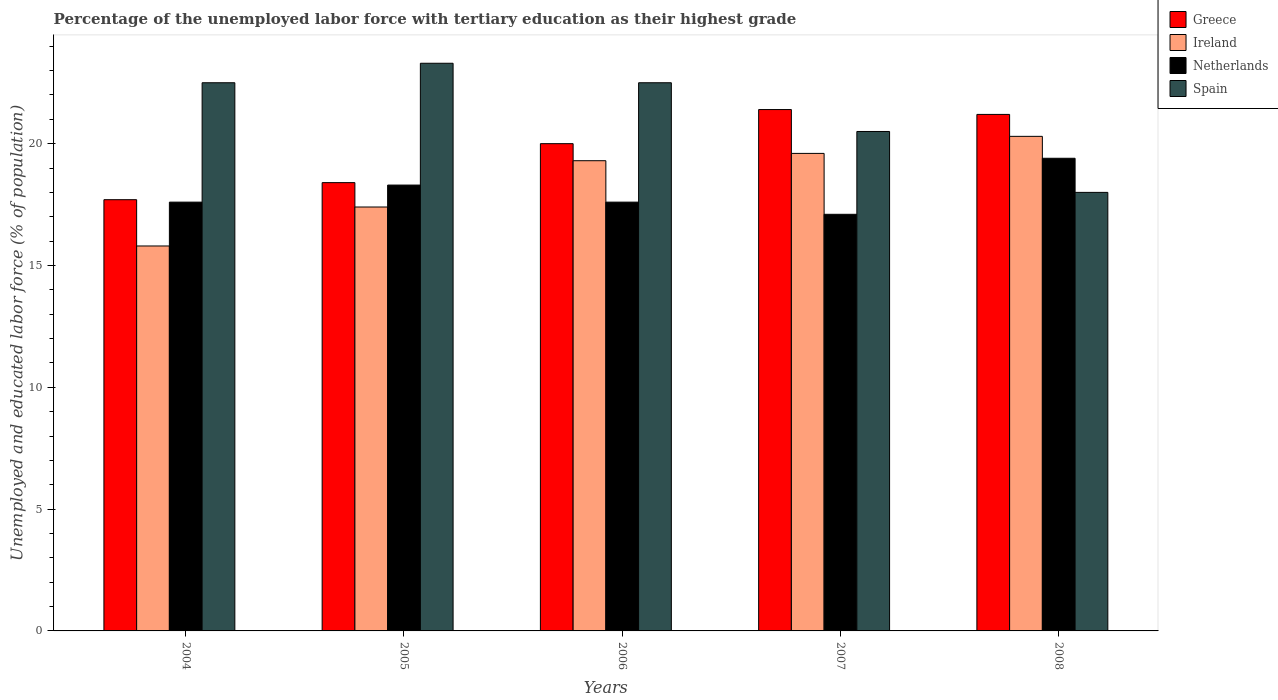How many different coloured bars are there?
Make the answer very short. 4. How many groups of bars are there?
Your answer should be compact. 5. Are the number of bars on each tick of the X-axis equal?
Your answer should be compact. Yes. How many bars are there on the 2nd tick from the left?
Your answer should be compact. 4. What is the percentage of the unemployed labor force with tertiary education in Ireland in 2005?
Your answer should be very brief. 17.4. Across all years, what is the maximum percentage of the unemployed labor force with tertiary education in Spain?
Offer a terse response. 23.3. In which year was the percentage of the unemployed labor force with tertiary education in Spain minimum?
Keep it short and to the point. 2008. What is the total percentage of the unemployed labor force with tertiary education in Spain in the graph?
Ensure brevity in your answer.  106.8. What is the difference between the percentage of the unemployed labor force with tertiary education in Netherlands in 2008 and the percentage of the unemployed labor force with tertiary education in Spain in 2005?
Provide a short and direct response. -3.9. What is the average percentage of the unemployed labor force with tertiary education in Ireland per year?
Ensure brevity in your answer.  18.48. In the year 2006, what is the difference between the percentage of the unemployed labor force with tertiary education in Ireland and percentage of the unemployed labor force with tertiary education in Greece?
Keep it short and to the point. -0.7. What is the ratio of the percentage of the unemployed labor force with tertiary education in Spain in 2004 to that in 2008?
Offer a terse response. 1.25. Is the difference between the percentage of the unemployed labor force with tertiary education in Ireland in 2005 and 2008 greater than the difference between the percentage of the unemployed labor force with tertiary education in Greece in 2005 and 2008?
Make the answer very short. No. What is the difference between the highest and the second highest percentage of the unemployed labor force with tertiary education in Greece?
Your answer should be compact. 0.2. What is the difference between the highest and the lowest percentage of the unemployed labor force with tertiary education in Greece?
Your answer should be very brief. 3.7. In how many years, is the percentage of the unemployed labor force with tertiary education in Greece greater than the average percentage of the unemployed labor force with tertiary education in Greece taken over all years?
Make the answer very short. 3. What does the 1st bar from the left in 2004 represents?
Your response must be concise. Greece. Is it the case that in every year, the sum of the percentage of the unemployed labor force with tertiary education in Ireland and percentage of the unemployed labor force with tertiary education in Netherlands is greater than the percentage of the unemployed labor force with tertiary education in Spain?
Offer a very short reply. Yes. Are all the bars in the graph horizontal?
Your response must be concise. No. How many years are there in the graph?
Give a very brief answer. 5. What is the difference between two consecutive major ticks on the Y-axis?
Offer a very short reply. 5. Are the values on the major ticks of Y-axis written in scientific E-notation?
Your answer should be compact. No. Does the graph contain any zero values?
Provide a succinct answer. No. Where does the legend appear in the graph?
Offer a very short reply. Top right. How many legend labels are there?
Provide a short and direct response. 4. How are the legend labels stacked?
Your answer should be compact. Vertical. What is the title of the graph?
Offer a very short reply. Percentage of the unemployed labor force with tertiary education as their highest grade. Does "East Asia (all income levels)" appear as one of the legend labels in the graph?
Offer a very short reply. No. What is the label or title of the X-axis?
Make the answer very short. Years. What is the label or title of the Y-axis?
Give a very brief answer. Unemployed and educated labor force (% of population). What is the Unemployed and educated labor force (% of population) of Greece in 2004?
Your answer should be very brief. 17.7. What is the Unemployed and educated labor force (% of population) of Ireland in 2004?
Your answer should be compact. 15.8. What is the Unemployed and educated labor force (% of population) of Netherlands in 2004?
Make the answer very short. 17.6. What is the Unemployed and educated labor force (% of population) of Greece in 2005?
Ensure brevity in your answer.  18.4. What is the Unemployed and educated labor force (% of population) in Ireland in 2005?
Provide a succinct answer. 17.4. What is the Unemployed and educated labor force (% of population) of Netherlands in 2005?
Give a very brief answer. 18.3. What is the Unemployed and educated labor force (% of population) in Spain in 2005?
Offer a terse response. 23.3. What is the Unemployed and educated labor force (% of population) of Ireland in 2006?
Your answer should be compact. 19.3. What is the Unemployed and educated labor force (% of population) in Netherlands in 2006?
Ensure brevity in your answer.  17.6. What is the Unemployed and educated labor force (% of population) of Greece in 2007?
Make the answer very short. 21.4. What is the Unemployed and educated labor force (% of population) of Ireland in 2007?
Give a very brief answer. 19.6. What is the Unemployed and educated labor force (% of population) of Netherlands in 2007?
Ensure brevity in your answer.  17.1. What is the Unemployed and educated labor force (% of population) of Spain in 2007?
Your answer should be very brief. 20.5. What is the Unemployed and educated labor force (% of population) in Greece in 2008?
Give a very brief answer. 21.2. What is the Unemployed and educated labor force (% of population) in Ireland in 2008?
Keep it short and to the point. 20.3. What is the Unemployed and educated labor force (% of population) in Netherlands in 2008?
Ensure brevity in your answer.  19.4. What is the Unemployed and educated labor force (% of population) in Spain in 2008?
Your response must be concise. 18. Across all years, what is the maximum Unemployed and educated labor force (% of population) in Greece?
Make the answer very short. 21.4. Across all years, what is the maximum Unemployed and educated labor force (% of population) in Ireland?
Your response must be concise. 20.3. Across all years, what is the maximum Unemployed and educated labor force (% of population) in Netherlands?
Your answer should be compact. 19.4. Across all years, what is the maximum Unemployed and educated labor force (% of population) of Spain?
Offer a terse response. 23.3. Across all years, what is the minimum Unemployed and educated labor force (% of population) in Greece?
Make the answer very short. 17.7. Across all years, what is the minimum Unemployed and educated labor force (% of population) in Ireland?
Your answer should be very brief. 15.8. Across all years, what is the minimum Unemployed and educated labor force (% of population) of Netherlands?
Ensure brevity in your answer.  17.1. Across all years, what is the minimum Unemployed and educated labor force (% of population) in Spain?
Your answer should be compact. 18. What is the total Unemployed and educated labor force (% of population) of Greece in the graph?
Ensure brevity in your answer.  98.7. What is the total Unemployed and educated labor force (% of population) in Ireland in the graph?
Offer a terse response. 92.4. What is the total Unemployed and educated labor force (% of population) in Spain in the graph?
Offer a very short reply. 106.8. What is the difference between the Unemployed and educated labor force (% of population) of Netherlands in 2004 and that in 2005?
Keep it short and to the point. -0.7. What is the difference between the Unemployed and educated labor force (% of population) in Spain in 2004 and that in 2005?
Offer a terse response. -0.8. What is the difference between the Unemployed and educated labor force (% of population) in Greece in 2004 and that in 2007?
Your answer should be compact. -3.7. What is the difference between the Unemployed and educated labor force (% of population) of Netherlands in 2004 and that in 2008?
Offer a terse response. -1.8. What is the difference between the Unemployed and educated labor force (% of population) in Ireland in 2005 and that in 2006?
Your answer should be very brief. -1.9. What is the difference between the Unemployed and educated labor force (% of population) of Netherlands in 2005 and that in 2006?
Provide a succinct answer. 0.7. What is the difference between the Unemployed and educated labor force (% of population) of Spain in 2005 and that in 2006?
Give a very brief answer. 0.8. What is the difference between the Unemployed and educated labor force (% of population) in Netherlands in 2005 and that in 2007?
Offer a terse response. 1.2. What is the difference between the Unemployed and educated labor force (% of population) of Spain in 2005 and that in 2007?
Offer a very short reply. 2.8. What is the difference between the Unemployed and educated labor force (% of population) of Greece in 2005 and that in 2008?
Provide a short and direct response. -2.8. What is the difference between the Unemployed and educated labor force (% of population) of Ireland in 2005 and that in 2008?
Offer a terse response. -2.9. What is the difference between the Unemployed and educated labor force (% of population) in Spain in 2005 and that in 2008?
Keep it short and to the point. 5.3. What is the difference between the Unemployed and educated labor force (% of population) in Greece in 2006 and that in 2007?
Your response must be concise. -1.4. What is the difference between the Unemployed and educated labor force (% of population) of Netherlands in 2006 and that in 2007?
Offer a terse response. 0.5. What is the difference between the Unemployed and educated labor force (% of population) in Spain in 2006 and that in 2007?
Make the answer very short. 2. What is the difference between the Unemployed and educated labor force (% of population) in Ireland in 2007 and that in 2008?
Give a very brief answer. -0.7. What is the difference between the Unemployed and educated labor force (% of population) of Greece in 2004 and the Unemployed and educated labor force (% of population) of Netherlands in 2005?
Your response must be concise. -0.6. What is the difference between the Unemployed and educated labor force (% of population) in Greece in 2004 and the Unemployed and educated labor force (% of population) in Spain in 2005?
Give a very brief answer. -5.6. What is the difference between the Unemployed and educated labor force (% of population) of Ireland in 2004 and the Unemployed and educated labor force (% of population) of Netherlands in 2005?
Give a very brief answer. -2.5. What is the difference between the Unemployed and educated labor force (% of population) of Greece in 2004 and the Unemployed and educated labor force (% of population) of Netherlands in 2006?
Ensure brevity in your answer.  0.1. What is the difference between the Unemployed and educated labor force (% of population) in Greece in 2004 and the Unemployed and educated labor force (% of population) in Spain in 2006?
Keep it short and to the point. -4.8. What is the difference between the Unemployed and educated labor force (% of population) of Greece in 2004 and the Unemployed and educated labor force (% of population) of Netherlands in 2007?
Your answer should be compact. 0.6. What is the difference between the Unemployed and educated labor force (% of population) in Ireland in 2004 and the Unemployed and educated labor force (% of population) in Netherlands in 2007?
Make the answer very short. -1.3. What is the difference between the Unemployed and educated labor force (% of population) in Ireland in 2004 and the Unemployed and educated labor force (% of population) in Spain in 2007?
Your response must be concise. -4.7. What is the difference between the Unemployed and educated labor force (% of population) in Greece in 2004 and the Unemployed and educated labor force (% of population) in Netherlands in 2008?
Your answer should be very brief. -1.7. What is the difference between the Unemployed and educated labor force (% of population) of Greece in 2004 and the Unemployed and educated labor force (% of population) of Spain in 2008?
Make the answer very short. -0.3. What is the difference between the Unemployed and educated labor force (% of population) of Ireland in 2004 and the Unemployed and educated labor force (% of population) of Netherlands in 2008?
Ensure brevity in your answer.  -3.6. What is the difference between the Unemployed and educated labor force (% of population) in Ireland in 2004 and the Unemployed and educated labor force (% of population) in Spain in 2008?
Offer a very short reply. -2.2. What is the difference between the Unemployed and educated labor force (% of population) in Netherlands in 2004 and the Unemployed and educated labor force (% of population) in Spain in 2008?
Offer a terse response. -0.4. What is the difference between the Unemployed and educated labor force (% of population) of Greece in 2005 and the Unemployed and educated labor force (% of population) of Ireland in 2006?
Your response must be concise. -0.9. What is the difference between the Unemployed and educated labor force (% of population) of Greece in 2005 and the Unemployed and educated labor force (% of population) of Netherlands in 2006?
Offer a terse response. 0.8. What is the difference between the Unemployed and educated labor force (% of population) of Ireland in 2005 and the Unemployed and educated labor force (% of population) of Netherlands in 2006?
Your answer should be compact. -0.2. What is the difference between the Unemployed and educated labor force (% of population) in Ireland in 2005 and the Unemployed and educated labor force (% of population) in Spain in 2006?
Your answer should be very brief. -5.1. What is the difference between the Unemployed and educated labor force (% of population) in Greece in 2005 and the Unemployed and educated labor force (% of population) in Ireland in 2007?
Offer a very short reply. -1.2. What is the difference between the Unemployed and educated labor force (% of population) in Greece in 2005 and the Unemployed and educated labor force (% of population) in Netherlands in 2007?
Provide a short and direct response. 1.3. What is the difference between the Unemployed and educated labor force (% of population) in Ireland in 2005 and the Unemployed and educated labor force (% of population) in Netherlands in 2007?
Your answer should be compact. 0.3. What is the difference between the Unemployed and educated labor force (% of population) of Netherlands in 2005 and the Unemployed and educated labor force (% of population) of Spain in 2007?
Provide a succinct answer. -2.2. What is the difference between the Unemployed and educated labor force (% of population) of Greece in 2005 and the Unemployed and educated labor force (% of population) of Ireland in 2008?
Provide a short and direct response. -1.9. What is the difference between the Unemployed and educated labor force (% of population) of Greece in 2005 and the Unemployed and educated labor force (% of population) of Netherlands in 2008?
Keep it short and to the point. -1. What is the difference between the Unemployed and educated labor force (% of population) in Ireland in 2005 and the Unemployed and educated labor force (% of population) in Spain in 2008?
Your answer should be compact. -0.6. What is the difference between the Unemployed and educated labor force (% of population) in Ireland in 2006 and the Unemployed and educated labor force (% of population) in Spain in 2007?
Offer a terse response. -1.2. What is the difference between the Unemployed and educated labor force (% of population) of Netherlands in 2006 and the Unemployed and educated labor force (% of population) of Spain in 2007?
Ensure brevity in your answer.  -2.9. What is the difference between the Unemployed and educated labor force (% of population) of Greece in 2006 and the Unemployed and educated labor force (% of population) of Netherlands in 2008?
Your response must be concise. 0.6. What is the difference between the Unemployed and educated labor force (% of population) of Ireland in 2006 and the Unemployed and educated labor force (% of population) of Netherlands in 2008?
Your response must be concise. -0.1. What is the difference between the Unemployed and educated labor force (% of population) of Netherlands in 2006 and the Unemployed and educated labor force (% of population) of Spain in 2008?
Offer a terse response. -0.4. What is the difference between the Unemployed and educated labor force (% of population) in Greece in 2007 and the Unemployed and educated labor force (% of population) in Ireland in 2008?
Offer a terse response. 1.1. What is the difference between the Unemployed and educated labor force (% of population) of Greece in 2007 and the Unemployed and educated labor force (% of population) of Netherlands in 2008?
Provide a succinct answer. 2. What is the difference between the Unemployed and educated labor force (% of population) in Greece in 2007 and the Unemployed and educated labor force (% of population) in Spain in 2008?
Your answer should be very brief. 3.4. What is the difference between the Unemployed and educated labor force (% of population) in Ireland in 2007 and the Unemployed and educated labor force (% of population) in Netherlands in 2008?
Give a very brief answer. 0.2. What is the difference between the Unemployed and educated labor force (% of population) in Netherlands in 2007 and the Unemployed and educated labor force (% of population) in Spain in 2008?
Offer a terse response. -0.9. What is the average Unemployed and educated labor force (% of population) in Greece per year?
Give a very brief answer. 19.74. What is the average Unemployed and educated labor force (% of population) of Ireland per year?
Make the answer very short. 18.48. What is the average Unemployed and educated labor force (% of population) in Spain per year?
Your answer should be compact. 21.36. In the year 2004, what is the difference between the Unemployed and educated labor force (% of population) in Greece and Unemployed and educated labor force (% of population) in Ireland?
Keep it short and to the point. 1.9. In the year 2005, what is the difference between the Unemployed and educated labor force (% of population) in Greece and Unemployed and educated labor force (% of population) in Ireland?
Your response must be concise. 1. In the year 2005, what is the difference between the Unemployed and educated labor force (% of population) in Greece and Unemployed and educated labor force (% of population) in Spain?
Your response must be concise. -4.9. In the year 2006, what is the difference between the Unemployed and educated labor force (% of population) in Greece and Unemployed and educated labor force (% of population) in Ireland?
Ensure brevity in your answer.  0.7. In the year 2006, what is the difference between the Unemployed and educated labor force (% of population) in Greece and Unemployed and educated labor force (% of population) in Netherlands?
Ensure brevity in your answer.  2.4. In the year 2006, what is the difference between the Unemployed and educated labor force (% of population) of Greece and Unemployed and educated labor force (% of population) of Spain?
Ensure brevity in your answer.  -2.5. In the year 2006, what is the difference between the Unemployed and educated labor force (% of population) of Netherlands and Unemployed and educated labor force (% of population) of Spain?
Make the answer very short. -4.9. In the year 2007, what is the difference between the Unemployed and educated labor force (% of population) in Greece and Unemployed and educated labor force (% of population) in Ireland?
Offer a very short reply. 1.8. In the year 2007, what is the difference between the Unemployed and educated labor force (% of population) in Ireland and Unemployed and educated labor force (% of population) in Netherlands?
Keep it short and to the point. 2.5. In the year 2008, what is the difference between the Unemployed and educated labor force (% of population) in Greece and Unemployed and educated labor force (% of population) in Netherlands?
Provide a succinct answer. 1.8. In the year 2008, what is the difference between the Unemployed and educated labor force (% of population) in Ireland and Unemployed and educated labor force (% of population) in Netherlands?
Give a very brief answer. 0.9. In the year 2008, what is the difference between the Unemployed and educated labor force (% of population) of Ireland and Unemployed and educated labor force (% of population) of Spain?
Offer a very short reply. 2.3. In the year 2008, what is the difference between the Unemployed and educated labor force (% of population) in Netherlands and Unemployed and educated labor force (% of population) in Spain?
Ensure brevity in your answer.  1.4. What is the ratio of the Unemployed and educated labor force (% of population) in Ireland in 2004 to that in 2005?
Your answer should be very brief. 0.91. What is the ratio of the Unemployed and educated labor force (% of population) of Netherlands in 2004 to that in 2005?
Give a very brief answer. 0.96. What is the ratio of the Unemployed and educated labor force (% of population) in Spain in 2004 to that in 2005?
Provide a short and direct response. 0.97. What is the ratio of the Unemployed and educated labor force (% of population) of Greece in 2004 to that in 2006?
Ensure brevity in your answer.  0.89. What is the ratio of the Unemployed and educated labor force (% of population) of Ireland in 2004 to that in 2006?
Ensure brevity in your answer.  0.82. What is the ratio of the Unemployed and educated labor force (% of population) of Spain in 2004 to that in 2006?
Offer a very short reply. 1. What is the ratio of the Unemployed and educated labor force (% of population) in Greece in 2004 to that in 2007?
Ensure brevity in your answer.  0.83. What is the ratio of the Unemployed and educated labor force (% of population) in Ireland in 2004 to that in 2007?
Offer a very short reply. 0.81. What is the ratio of the Unemployed and educated labor force (% of population) in Netherlands in 2004 to that in 2007?
Keep it short and to the point. 1.03. What is the ratio of the Unemployed and educated labor force (% of population) of Spain in 2004 to that in 2007?
Your answer should be very brief. 1.1. What is the ratio of the Unemployed and educated labor force (% of population) of Greece in 2004 to that in 2008?
Your answer should be compact. 0.83. What is the ratio of the Unemployed and educated labor force (% of population) in Ireland in 2004 to that in 2008?
Ensure brevity in your answer.  0.78. What is the ratio of the Unemployed and educated labor force (% of population) of Netherlands in 2004 to that in 2008?
Your answer should be very brief. 0.91. What is the ratio of the Unemployed and educated labor force (% of population) in Ireland in 2005 to that in 2006?
Ensure brevity in your answer.  0.9. What is the ratio of the Unemployed and educated labor force (% of population) of Netherlands in 2005 to that in 2006?
Provide a short and direct response. 1.04. What is the ratio of the Unemployed and educated labor force (% of population) of Spain in 2005 to that in 2006?
Your answer should be very brief. 1.04. What is the ratio of the Unemployed and educated labor force (% of population) in Greece in 2005 to that in 2007?
Ensure brevity in your answer.  0.86. What is the ratio of the Unemployed and educated labor force (% of population) in Ireland in 2005 to that in 2007?
Ensure brevity in your answer.  0.89. What is the ratio of the Unemployed and educated labor force (% of population) in Netherlands in 2005 to that in 2007?
Offer a very short reply. 1.07. What is the ratio of the Unemployed and educated labor force (% of population) of Spain in 2005 to that in 2007?
Offer a very short reply. 1.14. What is the ratio of the Unemployed and educated labor force (% of population) of Greece in 2005 to that in 2008?
Offer a terse response. 0.87. What is the ratio of the Unemployed and educated labor force (% of population) in Netherlands in 2005 to that in 2008?
Offer a terse response. 0.94. What is the ratio of the Unemployed and educated labor force (% of population) of Spain in 2005 to that in 2008?
Offer a very short reply. 1.29. What is the ratio of the Unemployed and educated labor force (% of population) of Greece in 2006 to that in 2007?
Your response must be concise. 0.93. What is the ratio of the Unemployed and educated labor force (% of population) in Ireland in 2006 to that in 2007?
Your response must be concise. 0.98. What is the ratio of the Unemployed and educated labor force (% of population) in Netherlands in 2006 to that in 2007?
Make the answer very short. 1.03. What is the ratio of the Unemployed and educated labor force (% of population) in Spain in 2006 to that in 2007?
Keep it short and to the point. 1.1. What is the ratio of the Unemployed and educated labor force (% of population) of Greece in 2006 to that in 2008?
Make the answer very short. 0.94. What is the ratio of the Unemployed and educated labor force (% of population) of Ireland in 2006 to that in 2008?
Offer a terse response. 0.95. What is the ratio of the Unemployed and educated labor force (% of population) in Netherlands in 2006 to that in 2008?
Make the answer very short. 0.91. What is the ratio of the Unemployed and educated labor force (% of population) in Spain in 2006 to that in 2008?
Your response must be concise. 1.25. What is the ratio of the Unemployed and educated labor force (% of population) of Greece in 2007 to that in 2008?
Your answer should be very brief. 1.01. What is the ratio of the Unemployed and educated labor force (% of population) in Ireland in 2007 to that in 2008?
Your answer should be very brief. 0.97. What is the ratio of the Unemployed and educated labor force (% of population) of Netherlands in 2007 to that in 2008?
Keep it short and to the point. 0.88. What is the ratio of the Unemployed and educated labor force (% of population) of Spain in 2007 to that in 2008?
Give a very brief answer. 1.14. What is the difference between the highest and the second highest Unemployed and educated labor force (% of population) of Ireland?
Your answer should be very brief. 0.7. What is the difference between the highest and the second highest Unemployed and educated labor force (% of population) in Netherlands?
Offer a very short reply. 1.1. What is the difference between the highest and the second highest Unemployed and educated labor force (% of population) in Spain?
Give a very brief answer. 0.8. What is the difference between the highest and the lowest Unemployed and educated labor force (% of population) of Ireland?
Give a very brief answer. 4.5. 